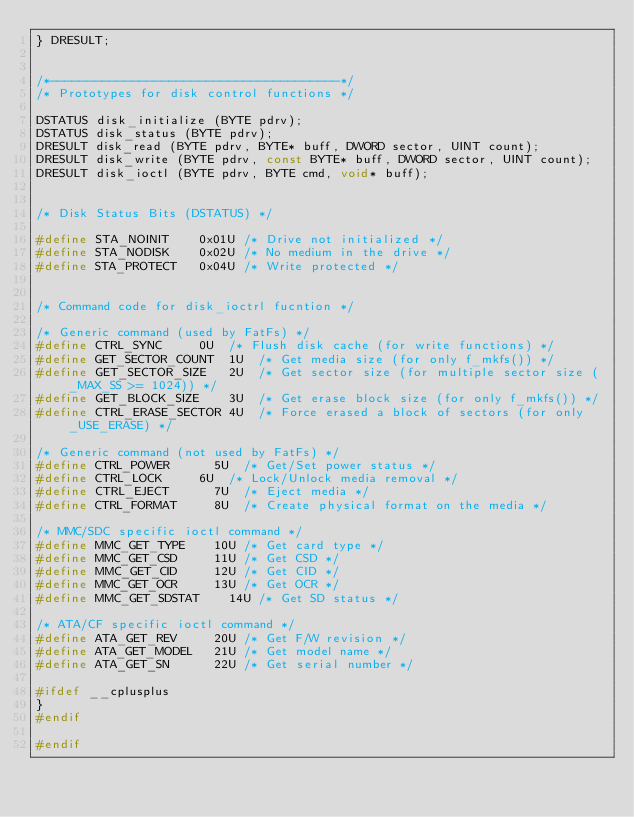Convert code to text. <code><loc_0><loc_0><loc_500><loc_500><_C_>} DRESULT;


/*---------------------------------------*/
/* Prototypes for disk control functions */

DSTATUS disk_initialize (BYTE pdrv);
DSTATUS disk_status (BYTE pdrv);
DRESULT disk_read (BYTE pdrv, BYTE* buff, DWORD sector, UINT count);
DRESULT disk_write (BYTE pdrv, const BYTE* buff, DWORD sector, UINT count);
DRESULT disk_ioctl (BYTE pdrv, BYTE cmd, void* buff);


/* Disk Status Bits (DSTATUS) */

#define STA_NOINIT		0x01U	/* Drive not initialized */
#define STA_NODISK		0x02U	/* No medium in the drive */
#define STA_PROTECT		0x04U	/* Write protected */


/* Command code for disk_ioctrl fucntion */

/* Generic command (used by FatFs) */
#define CTRL_SYNC			0U	/* Flush disk cache (for write functions) */
#define GET_SECTOR_COUNT	1U	/* Get media size (for only f_mkfs()) */
#define GET_SECTOR_SIZE		2U	/* Get sector size (for multiple sector size (_MAX_SS >= 1024)) */
#define GET_BLOCK_SIZE		3U	/* Get erase block size (for only f_mkfs()) */
#define CTRL_ERASE_SECTOR	4U	/* Force erased a block of sectors (for only _USE_ERASE) */

/* Generic command (not used by FatFs) */
#define CTRL_POWER			5U	/* Get/Set power status */
#define CTRL_LOCK			6U	/* Lock/Unlock media removal */
#define CTRL_EJECT			7U	/* Eject media */
#define CTRL_FORMAT			8U	/* Create physical format on the media */

/* MMC/SDC specific ioctl command */
#define MMC_GET_TYPE		10U	/* Get card type */
#define MMC_GET_CSD			11U	/* Get CSD */
#define MMC_GET_CID			12U	/* Get CID */
#define MMC_GET_OCR			13U	/* Get OCR */
#define MMC_GET_SDSTAT		14U	/* Get SD status */

/* ATA/CF specific ioctl command */
#define ATA_GET_REV			20U	/* Get F/W revision */
#define ATA_GET_MODEL		21U	/* Get model name */
#define ATA_GET_SN			22U	/* Get serial number */

#ifdef __cplusplus
}
#endif

#endif
</code> 